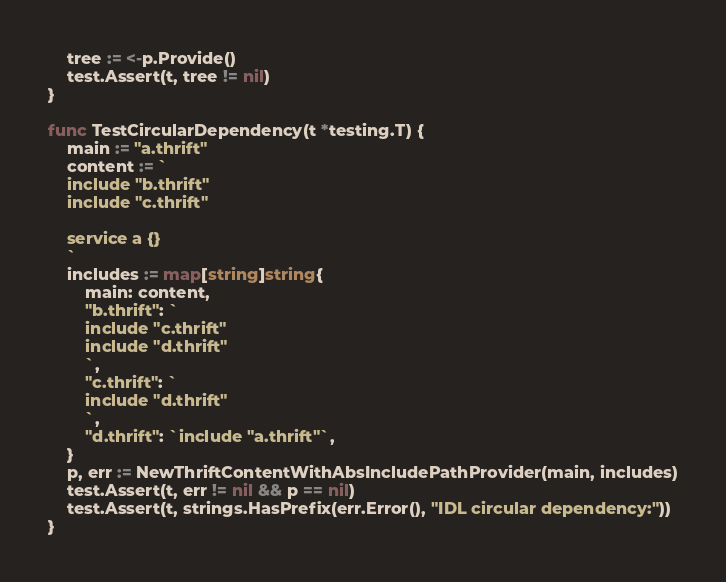<code> <loc_0><loc_0><loc_500><loc_500><_Go_>	tree := <-p.Provide()
	test.Assert(t, tree != nil)
}

func TestCircularDependency(t *testing.T) {
	main := "a.thrift"
	content := `
	include "b.thrift"
	include "c.thrift" 

	service a {}
	`
	includes := map[string]string{
		main: content,
		"b.thrift": `
		include "c.thrift"
		include "d.thrift"
		`,
		"c.thrift": `
		include "d.thrift"
		`,
		"d.thrift": `include "a.thrift"`,
	}
	p, err := NewThriftContentWithAbsIncludePathProvider(main, includes)
	test.Assert(t, err != nil && p == nil)
	test.Assert(t, strings.HasPrefix(err.Error(), "IDL circular dependency:"))
}
</code> 